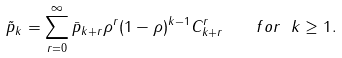<formula> <loc_0><loc_0><loc_500><loc_500>\tilde { p } _ { k } = \sum _ { r = 0 } ^ { \infty } \bar { p } _ { k + r } \rho ^ { r } ( 1 - \rho ) ^ { k - 1 } C _ { k + r } ^ { r } \quad f o r \ k \geq 1 .</formula> 